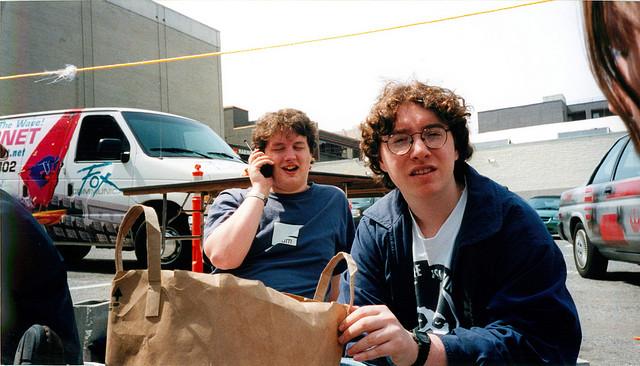Is that a catering van?
Quick response, please. No. What is in front of the person with glasses?
Write a very short answer. Bag. Of the two figures sitting in the middle of the photo, which is sitting closer to the viewer?
Quick response, please. Right. What else are they holding besides the signs?
Give a very brief answer. Bag. 